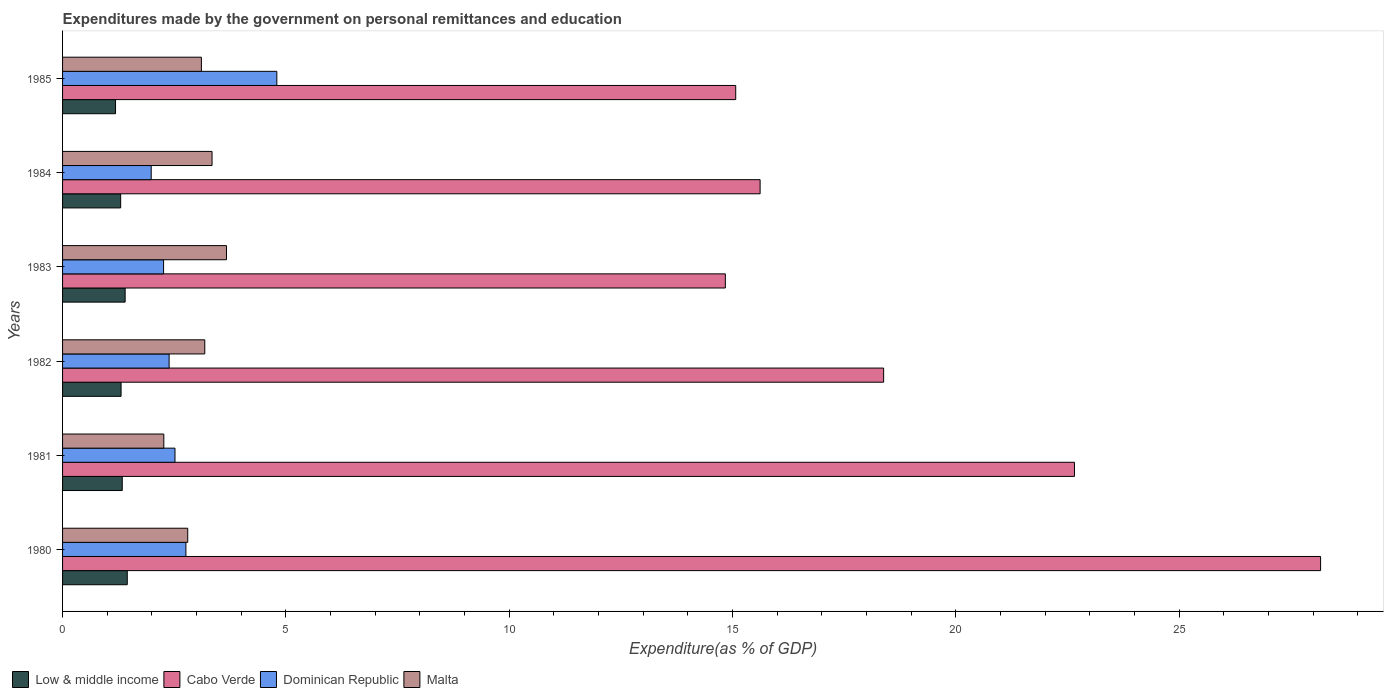How many different coloured bars are there?
Your answer should be compact. 4. Are the number of bars per tick equal to the number of legend labels?
Provide a short and direct response. Yes. How many bars are there on the 3rd tick from the bottom?
Provide a succinct answer. 4. What is the label of the 1st group of bars from the top?
Your answer should be compact. 1985. In how many cases, is the number of bars for a given year not equal to the number of legend labels?
Your answer should be very brief. 0. What is the expenditures made by the government on personal remittances and education in Low & middle income in 1980?
Offer a very short reply. 1.45. Across all years, what is the maximum expenditures made by the government on personal remittances and education in Cabo Verde?
Provide a succinct answer. 28.17. Across all years, what is the minimum expenditures made by the government on personal remittances and education in Malta?
Offer a terse response. 2.27. In which year was the expenditures made by the government on personal remittances and education in Cabo Verde maximum?
Your answer should be very brief. 1980. What is the total expenditures made by the government on personal remittances and education in Cabo Verde in the graph?
Give a very brief answer. 114.73. What is the difference between the expenditures made by the government on personal remittances and education in Malta in 1982 and that in 1983?
Give a very brief answer. -0.49. What is the difference between the expenditures made by the government on personal remittances and education in Low & middle income in 1983 and the expenditures made by the government on personal remittances and education in Cabo Verde in 1984?
Provide a succinct answer. -14.22. What is the average expenditures made by the government on personal remittances and education in Malta per year?
Offer a very short reply. 3.06. In the year 1981, what is the difference between the expenditures made by the government on personal remittances and education in Dominican Republic and expenditures made by the government on personal remittances and education in Low & middle income?
Your answer should be very brief. 1.18. What is the ratio of the expenditures made by the government on personal remittances and education in Low & middle income in 1980 to that in 1985?
Make the answer very short. 1.22. Is the expenditures made by the government on personal remittances and education in Low & middle income in 1981 less than that in 1983?
Give a very brief answer. Yes. What is the difference between the highest and the second highest expenditures made by the government on personal remittances and education in Dominican Republic?
Your answer should be very brief. 2.04. What is the difference between the highest and the lowest expenditures made by the government on personal remittances and education in Dominican Republic?
Your response must be concise. 2.81. In how many years, is the expenditures made by the government on personal remittances and education in Cabo Verde greater than the average expenditures made by the government on personal remittances and education in Cabo Verde taken over all years?
Give a very brief answer. 2. Is the sum of the expenditures made by the government on personal remittances and education in Dominican Republic in 1981 and 1985 greater than the maximum expenditures made by the government on personal remittances and education in Cabo Verde across all years?
Your answer should be compact. No. What does the 1st bar from the top in 1981 represents?
Offer a terse response. Malta. What does the 1st bar from the bottom in 1985 represents?
Provide a succinct answer. Low & middle income. Is it the case that in every year, the sum of the expenditures made by the government on personal remittances and education in Dominican Republic and expenditures made by the government on personal remittances and education in Cabo Verde is greater than the expenditures made by the government on personal remittances and education in Malta?
Offer a very short reply. Yes. How many bars are there?
Ensure brevity in your answer.  24. Are all the bars in the graph horizontal?
Offer a very short reply. Yes. Does the graph contain any zero values?
Your answer should be very brief. No. Does the graph contain grids?
Offer a terse response. No. How many legend labels are there?
Ensure brevity in your answer.  4. How are the legend labels stacked?
Keep it short and to the point. Horizontal. What is the title of the graph?
Offer a very short reply. Expenditures made by the government on personal remittances and education. What is the label or title of the X-axis?
Your answer should be compact. Expenditure(as % of GDP). What is the label or title of the Y-axis?
Keep it short and to the point. Years. What is the Expenditure(as % of GDP) in Low & middle income in 1980?
Provide a short and direct response. 1.45. What is the Expenditure(as % of GDP) of Cabo Verde in 1980?
Ensure brevity in your answer.  28.17. What is the Expenditure(as % of GDP) in Dominican Republic in 1980?
Offer a terse response. 2.76. What is the Expenditure(as % of GDP) in Malta in 1980?
Keep it short and to the point. 2.8. What is the Expenditure(as % of GDP) in Low & middle income in 1981?
Your answer should be compact. 1.34. What is the Expenditure(as % of GDP) in Cabo Verde in 1981?
Offer a very short reply. 22.66. What is the Expenditure(as % of GDP) in Dominican Republic in 1981?
Provide a succinct answer. 2.52. What is the Expenditure(as % of GDP) in Malta in 1981?
Your response must be concise. 2.27. What is the Expenditure(as % of GDP) in Low & middle income in 1982?
Your answer should be very brief. 1.31. What is the Expenditure(as % of GDP) in Cabo Verde in 1982?
Offer a very short reply. 18.38. What is the Expenditure(as % of GDP) in Dominican Republic in 1982?
Provide a short and direct response. 2.39. What is the Expenditure(as % of GDP) of Malta in 1982?
Your response must be concise. 3.18. What is the Expenditure(as % of GDP) in Low & middle income in 1983?
Your answer should be compact. 1.4. What is the Expenditure(as % of GDP) of Cabo Verde in 1983?
Offer a terse response. 14.84. What is the Expenditure(as % of GDP) of Dominican Republic in 1983?
Offer a terse response. 2.26. What is the Expenditure(as % of GDP) of Malta in 1983?
Give a very brief answer. 3.67. What is the Expenditure(as % of GDP) of Low & middle income in 1984?
Keep it short and to the point. 1.3. What is the Expenditure(as % of GDP) in Cabo Verde in 1984?
Give a very brief answer. 15.62. What is the Expenditure(as % of GDP) of Dominican Republic in 1984?
Provide a short and direct response. 1.98. What is the Expenditure(as % of GDP) in Malta in 1984?
Give a very brief answer. 3.35. What is the Expenditure(as % of GDP) in Low & middle income in 1985?
Ensure brevity in your answer.  1.19. What is the Expenditure(as % of GDP) of Cabo Verde in 1985?
Your response must be concise. 15.07. What is the Expenditure(as % of GDP) of Dominican Republic in 1985?
Provide a short and direct response. 4.8. What is the Expenditure(as % of GDP) in Malta in 1985?
Offer a terse response. 3.11. Across all years, what is the maximum Expenditure(as % of GDP) of Low & middle income?
Make the answer very short. 1.45. Across all years, what is the maximum Expenditure(as % of GDP) in Cabo Verde?
Make the answer very short. 28.17. Across all years, what is the maximum Expenditure(as % of GDP) of Dominican Republic?
Keep it short and to the point. 4.8. Across all years, what is the maximum Expenditure(as % of GDP) of Malta?
Make the answer very short. 3.67. Across all years, what is the minimum Expenditure(as % of GDP) in Low & middle income?
Keep it short and to the point. 1.19. Across all years, what is the minimum Expenditure(as % of GDP) in Cabo Verde?
Your response must be concise. 14.84. Across all years, what is the minimum Expenditure(as % of GDP) of Dominican Republic?
Your answer should be very brief. 1.98. Across all years, what is the minimum Expenditure(as % of GDP) of Malta?
Ensure brevity in your answer.  2.27. What is the total Expenditure(as % of GDP) of Low & middle income in the graph?
Provide a short and direct response. 7.98. What is the total Expenditure(as % of GDP) of Cabo Verde in the graph?
Offer a very short reply. 114.73. What is the total Expenditure(as % of GDP) of Dominican Republic in the graph?
Give a very brief answer. 16.71. What is the total Expenditure(as % of GDP) in Malta in the graph?
Your response must be concise. 18.38. What is the difference between the Expenditure(as % of GDP) in Low & middle income in 1980 and that in 1981?
Ensure brevity in your answer.  0.11. What is the difference between the Expenditure(as % of GDP) in Cabo Verde in 1980 and that in 1981?
Make the answer very short. 5.51. What is the difference between the Expenditure(as % of GDP) in Dominican Republic in 1980 and that in 1981?
Provide a short and direct response. 0.24. What is the difference between the Expenditure(as % of GDP) in Malta in 1980 and that in 1981?
Your answer should be compact. 0.54. What is the difference between the Expenditure(as % of GDP) in Low & middle income in 1980 and that in 1982?
Ensure brevity in your answer.  0.14. What is the difference between the Expenditure(as % of GDP) of Cabo Verde in 1980 and that in 1982?
Your answer should be very brief. 9.78. What is the difference between the Expenditure(as % of GDP) in Dominican Republic in 1980 and that in 1982?
Provide a succinct answer. 0.38. What is the difference between the Expenditure(as % of GDP) in Malta in 1980 and that in 1982?
Your response must be concise. -0.38. What is the difference between the Expenditure(as % of GDP) in Low & middle income in 1980 and that in 1983?
Your answer should be compact. 0.05. What is the difference between the Expenditure(as % of GDP) in Cabo Verde in 1980 and that in 1983?
Offer a terse response. 13.33. What is the difference between the Expenditure(as % of GDP) in Dominican Republic in 1980 and that in 1983?
Give a very brief answer. 0.5. What is the difference between the Expenditure(as % of GDP) in Malta in 1980 and that in 1983?
Give a very brief answer. -0.87. What is the difference between the Expenditure(as % of GDP) of Low & middle income in 1980 and that in 1984?
Your response must be concise. 0.15. What is the difference between the Expenditure(as % of GDP) of Cabo Verde in 1980 and that in 1984?
Ensure brevity in your answer.  12.55. What is the difference between the Expenditure(as % of GDP) of Dominican Republic in 1980 and that in 1984?
Provide a succinct answer. 0.78. What is the difference between the Expenditure(as % of GDP) in Malta in 1980 and that in 1984?
Your answer should be very brief. -0.54. What is the difference between the Expenditure(as % of GDP) of Low & middle income in 1980 and that in 1985?
Your answer should be compact. 0.26. What is the difference between the Expenditure(as % of GDP) in Cabo Verde in 1980 and that in 1985?
Give a very brief answer. 13.09. What is the difference between the Expenditure(as % of GDP) in Dominican Republic in 1980 and that in 1985?
Keep it short and to the point. -2.04. What is the difference between the Expenditure(as % of GDP) in Malta in 1980 and that in 1985?
Give a very brief answer. -0.31. What is the difference between the Expenditure(as % of GDP) in Low & middle income in 1981 and that in 1982?
Offer a terse response. 0.03. What is the difference between the Expenditure(as % of GDP) of Cabo Verde in 1981 and that in 1982?
Ensure brevity in your answer.  4.27. What is the difference between the Expenditure(as % of GDP) of Dominican Republic in 1981 and that in 1982?
Your response must be concise. 0.13. What is the difference between the Expenditure(as % of GDP) in Malta in 1981 and that in 1982?
Give a very brief answer. -0.92. What is the difference between the Expenditure(as % of GDP) in Low & middle income in 1981 and that in 1983?
Provide a succinct answer. -0.06. What is the difference between the Expenditure(as % of GDP) in Cabo Verde in 1981 and that in 1983?
Your answer should be compact. 7.82. What is the difference between the Expenditure(as % of GDP) in Dominican Republic in 1981 and that in 1983?
Your answer should be very brief. 0.26. What is the difference between the Expenditure(as % of GDP) of Malta in 1981 and that in 1983?
Give a very brief answer. -1.4. What is the difference between the Expenditure(as % of GDP) of Low & middle income in 1981 and that in 1984?
Your answer should be compact. 0.04. What is the difference between the Expenditure(as % of GDP) in Cabo Verde in 1981 and that in 1984?
Your answer should be compact. 7.04. What is the difference between the Expenditure(as % of GDP) in Dominican Republic in 1981 and that in 1984?
Provide a succinct answer. 0.53. What is the difference between the Expenditure(as % of GDP) in Malta in 1981 and that in 1984?
Your answer should be compact. -1.08. What is the difference between the Expenditure(as % of GDP) in Low & middle income in 1981 and that in 1985?
Offer a terse response. 0.15. What is the difference between the Expenditure(as % of GDP) of Cabo Verde in 1981 and that in 1985?
Offer a terse response. 7.58. What is the difference between the Expenditure(as % of GDP) of Dominican Republic in 1981 and that in 1985?
Keep it short and to the point. -2.28. What is the difference between the Expenditure(as % of GDP) in Malta in 1981 and that in 1985?
Ensure brevity in your answer.  -0.84. What is the difference between the Expenditure(as % of GDP) in Low & middle income in 1982 and that in 1983?
Provide a succinct answer. -0.09. What is the difference between the Expenditure(as % of GDP) in Cabo Verde in 1982 and that in 1983?
Offer a very short reply. 3.54. What is the difference between the Expenditure(as % of GDP) of Dominican Republic in 1982 and that in 1983?
Keep it short and to the point. 0.12. What is the difference between the Expenditure(as % of GDP) of Malta in 1982 and that in 1983?
Offer a very short reply. -0.49. What is the difference between the Expenditure(as % of GDP) of Low & middle income in 1982 and that in 1984?
Your answer should be compact. 0.01. What is the difference between the Expenditure(as % of GDP) in Cabo Verde in 1982 and that in 1984?
Offer a very short reply. 2.77. What is the difference between the Expenditure(as % of GDP) of Dominican Republic in 1982 and that in 1984?
Offer a very short reply. 0.4. What is the difference between the Expenditure(as % of GDP) of Malta in 1982 and that in 1984?
Your answer should be compact. -0.16. What is the difference between the Expenditure(as % of GDP) in Low & middle income in 1982 and that in 1985?
Provide a short and direct response. 0.12. What is the difference between the Expenditure(as % of GDP) in Cabo Verde in 1982 and that in 1985?
Offer a terse response. 3.31. What is the difference between the Expenditure(as % of GDP) of Dominican Republic in 1982 and that in 1985?
Provide a succinct answer. -2.41. What is the difference between the Expenditure(as % of GDP) in Malta in 1982 and that in 1985?
Make the answer very short. 0.08. What is the difference between the Expenditure(as % of GDP) of Low & middle income in 1983 and that in 1984?
Keep it short and to the point. 0.1. What is the difference between the Expenditure(as % of GDP) in Cabo Verde in 1983 and that in 1984?
Make the answer very short. -0.78. What is the difference between the Expenditure(as % of GDP) in Dominican Republic in 1983 and that in 1984?
Keep it short and to the point. 0.28. What is the difference between the Expenditure(as % of GDP) in Malta in 1983 and that in 1984?
Offer a terse response. 0.32. What is the difference between the Expenditure(as % of GDP) of Low & middle income in 1983 and that in 1985?
Ensure brevity in your answer.  0.22. What is the difference between the Expenditure(as % of GDP) of Cabo Verde in 1983 and that in 1985?
Make the answer very short. -0.23. What is the difference between the Expenditure(as % of GDP) in Dominican Republic in 1983 and that in 1985?
Keep it short and to the point. -2.54. What is the difference between the Expenditure(as % of GDP) of Malta in 1983 and that in 1985?
Ensure brevity in your answer.  0.56. What is the difference between the Expenditure(as % of GDP) in Low & middle income in 1984 and that in 1985?
Give a very brief answer. 0.11. What is the difference between the Expenditure(as % of GDP) of Cabo Verde in 1984 and that in 1985?
Your answer should be compact. 0.55. What is the difference between the Expenditure(as % of GDP) of Dominican Republic in 1984 and that in 1985?
Your answer should be compact. -2.81. What is the difference between the Expenditure(as % of GDP) in Malta in 1984 and that in 1985?
Your response must be concise. 0.24. What is the difference between the Expenditure(as % of GDP) in Low & middle income in 1980 and the Expenditure(as % of GDP) in Cabo Verde in 1981?
Make the answer very short. -21.21. What is the difference between the Expenditure(as % of GDP) of Low & middle income in 1980 and the Expenditure(as % of GDP) of Dominican Republic in 1981?
Offer a very short reply. -1.07. What is the difference between the Expenditure(as % of GDP) in Low & middle income in 1980 and the Expenditure(as % of GDP) in Malta in 1981?
Your response must be concise. -0.82. What is the difference between the Expenditure(as % of GDP) of Cabo Verde in 1980 and the Expenditure(as % of GDP) of Dominican Republic in 1981?
Make the answer very short. 25.65. What is the difference between the Expenditure(as % of GDP) in Cabo Verde in 1980 and the Expenditure(as % of GDP) in Malta in 1981?
Your answer should be compact. 25.9. What is the difference between the Expenditure(as % of GDP) in Dominican Republic in 1980 and the Expenditure(as % of GDP) in Malta in 1981?
Give a very brief answer. 0.49. What is the difference between the Expenditure(as % of GDP) of Low & middle income in 1980 and the Expenditure(as % of GDP) of Cabo Verde in 1982?
Your response must be concise. -16.93. What is the difference between the Expenditure(as % of GDP) of Low & middle income in 1980 and the Expenditure(as % of GDP) of Dominican Republic in 1982?
Offer a very short reply. -0.94. What is the difference between the Expenditure(as % of GDP) in Low & middle income in 1980 and the Expenditure(as % of GDP) in Malta in 1982?
Ensure brevity in your answer.  -1.74. What is the difference between the Expenditure(as % of GDP) in Cabo Verde in 1980 and the Expenditure(as % of GDP) in Dominican Republic in 1982?
Your answer should be very brief. 25.78. What is the difference between the Expenditure(as % of GDP) in Cabo Verde in 1980 and the Expenditure(as % of GDP) in Malta in 1982?
Your answer should be compact. 24.98. What is the difference between the Expenditure(as % of GDP) of Dominican Republic in 1980 and the Expenditure(as % of GDP) of Malta in 1982?
Your answer should be very brief. -0.42. What is the difference between the Expenditure(as % of GDP) of Low & middle income in 1980 and the Expenditure(as % of GDP) of Cabo Verde in 1983?
Your answer should be compact. -13.39. What is the difference between the Expenditure(as % of GDP) in Low & middle income in 1980 and the Expenditure(as % of GDP) in Dominican Republic in 1983?
Your answer should be compact. -0.81. What is the difference between the Expenditure(as % of GDP) in Low & middle income in 1980 and the Expenditure(as % of GDP) in Malta in 1983?
Your answer should be very brief. -2.22. What is the difference between the Expenditure(as % of GDP) of Cabo Verde in 1980 and the Expenditure(as % of GDP) of Dominican Republic in 1983?
Ensure brevity in your answer.  25.9. What is the difference between the Expenditure(as % of GDP) in Cabo Verde in 1980 and the Expenditure(as % of GDP) in Malta in 1983?
Offer a terse response. 24.5. What is the difference between the Expenditure(as % of GDP) in Dominican Republic in 1980 and the Expenditure(as % of GDP) in Malta in 1983?
Provide a short and direct response. -0.91. What is the difference between the Expenditure(as % of GDP) of Low & middle income in 1980 and the Expenditure(as % of GDP) of Cabo Verde in 1984?
Offer a terse response. -14.17. What is the difference between the Expenditure(as % of GDP) of Low & middle income in 1980 and the Expenditure(as % of GDP) of Dominican Republic in 1984?
Your response must be concise. -0.54. What is the difference between the Expenditure(as % of GDP) in Low & middle income in 1980 and the Expenditure(as % of GDP) in Malta in 1984?
Provide a short and direct response. -1.9. What is the difference between the Expenditure(as % of GDP) in Cabo Verde in 1980 and the Expenditure(as % of GDP) in Dominican Republic in 1984?
Provide a succinct answer. 26.18. What is the difference between the Expenditure(as % of GDP) in Cabo Verde in 1980 and the Expenditure(as % of GDP) in Malta in 1984?
Offer a very short reply. 24.82. What is the difference between the Expenditure(as % of GDP) of Dominican Republic in 1980 and the Expenditure(as % of GDP) of Malta in 1984?
Make the answer very short. -0.59. What is the difference between the Expenditure(as % of GDP) of Low & middle income in 1980 and the Expenditure(as % of GDP) of Cabo Verde in 1985?
Offer a terse response. -13.62. What is the difference between the Expenditure(as % of GDP) in Low & middle income in 1980 and the Expenditure(as % of GDP) in Dominican Republic in 1985?
Make the answer very short. -3.35. What is the difference between the Expenditure(as % of GDP) of Low & middle income in 1980 and the Expenditure(as % of GDP) of Malta in 1985?
Your answer should be very brief. -1.66. What is the difference between the Expenditure(as % of GDP) in Cabo Verde in 1980 and the Expenditure(as % of GDP) in Dominican Republic in 1985?
Offer a very short reply. 23.37. What is the difference between the Expenditure(as % of GDP) of Cabo Verde in 1980 and the Expenditure(as % of GDP) of Malta in 1985?
Your response must be concise. 25.06. What is the difference between the Expenditure(as % of GDP) of Dominican Republic in 1980 and the Expenditure(as % of GDP) of Malta in 1985?
Your answer should be compact. -0.35. What is the difference between the Expenditure(as % of GDP) in Low & middle income in 1981 and the Expenditure(as % of GDP) in Cabo Verde in 1982?
Keep it short and to the point. -17.05. What is the difference between the Expenditure(as % of GDP) of Low & middle income in 1981 and the Expenditure(as % of GDP) of Dominican Republic in 1982?
Give a very brief answer. -1.05. What is the difference between the Expenditure(as % of GDP) of Low & middle income in 1981 and the Expenditure(as % of GDP) of Malta in 1982?
Ensure brevity in your answer.  -1.85. What is the difference between the Expenditure(as % of GDP) of Cabo Verde in 1981 and the Expenditure(as % of GDP) of Dominican Republic in 1982?
Keep it short and to the point. 20.27. What is the difference between the Expenditure(as % of GDP) of Cabo Verde in 1981 and the Expenditure(as % of GDP) of Malta in 1982?
Provide a short and direct response. 19.47. What is the difference between the Expenditure(as % of GDP) in Dominican Republic in 1981 and the Expenditure(as % of GDP) in Malta in 1982?
Provide a succinct answer. -0.67. What is the difference between the Expenditure(as % of GDP) of Low & middle income in 1981 and the Expenditure(as % of GDP) of Cabo Verde in 1983?
Keep it short and to the point. -13.5. What is the difference between the Expenditure(as % of GDP) of Low & middle income in 1981 and the Expenditure(as % of GDP) of Dominican Republic in 1983?
Ensure brevity in your answer.  -0.93. What is the difference between the Expenditure(as % of GDP) in Low & middle income in 1981 and the Expenditure(as % of GDP) in Malta in 1983?
Provide a short and direct response. -2.33. What is the difference between the Expenditure(as % of GDP) in Cabo Verde in 1981 and the Expenditure(as % of GDP) in Dominican Republic in 1983?
Your answer should be compact. 20.39. What is the difference between the Expenditure(as % of GDP) in Cabo Verde in 1981 and the Expenditure(as % of GDP) in Malta in 1983?
Provide a short and direct response. 18.99. What is the difference between the Expenditure(as % of GDP) in Dominican Republic in 1981 and the Expenditure(as % of GDP) in Malta in 1983?
Provide a succinct answer. -1.15. What is the difference between the Expenditure(as % of GDP) in Low & middle income in 1981 and the Expenditure(as % of GDP) in Cabo Verde in 1984?
Keep it short and to the point. -14.28. What is the difference between the Expenditure(as % of GDP) in Low & middle income in 1981 and the Expenditure(as % of GDP) in Dominican Republic in 1984?
Offer a very short reply. -0.65. What is the difference between the Expenditure(as % of GDP) in Low & middle income in 1981 and the Expenditure(as % of GDP) in Malta in 1984?
Ensure brevity in your answer.  -2.01. What is the difference between the Expenditure(as % of GDP) in Cabo Verde in 1981 and the Expenditure(as % of GDP) in Dominican Republic in 1984?
Your answer should be compact. 20.67. What is the difference between the Expenditure(as % of GDP) in Cabo Verde in 1981 and the Expenditure(as % of GDP) in Malta in 1984?
Offer a very short reply. 19.31. What is the difference between the Expenditure(as % of GDP) of Dominican Republic in 1981 and the Expenditure(as % of GDP) of Malta in 1984?
Keep it short and to the point. -0.83. What is the difference between the Expenditure(as % of GDP) in Low & middle income in 1981 and the Expenditure(as % of GDP) in Cabo Verde in 1985?
Offer a terse response. -13.73. What is the difference between the Expenditure(as % of GDP) in Low & middle income in 1981 and the Expenditure(as % of GDP) in Dominican Republic in 1985?
Your answer should be very brief. -3.46. What is the difference between the Expenditure(as % of GDP) of Low & middle income in 1981 and the Expenditure(as % of GDP) of Malta in 1985?
Provide a succinct answer. -1.77. What is the difference between the Expenditure(as % of GDP) of Cabo Verde in 1981 and the Expenditure(as % of GDP) of Dominican Republic in 1985?
Provide a short and direct response. 17.86. What is the difference between the Expenditure(as % of GDP) in Cabo Verde in 1981 and the Expenditure(as % of GDP) in Malta in 1985?
Your answer should be compact. 19.55. What is the difference between the Expenditure(as % of GDP) of Dominican Republic in 1981 and the Expenditure(as % of GDP) of Malta in 1985?
Your answer should be compact. -0.59. What is the difference between the Expenditure(as % of GDP) in Low & middle income in 1982 and the Expenditure(as % of GDP) in Cabo Verde in 1983?
Offer a terse response. -13.53. What is the difference between the Expenditure(as % of GDP) in Low & middle income in 1982 and the Expenditure(as % of GDP) in Dominican Republic in 1983?
Offer a very short reply. -0.95. What is the difference between the Expenditure(as % of GDP) in Low & middle income in 1982 and the Expenditure(as % of GDP) in Malta in 1983?
Offer a terse response. -2.36. What is the difference between the Expenditure(as % of GDP) of Cabo Verde in 1982 and the Expenditure(as % of GDP) of Dominican Republic in 1983?
Your answer should be compact. 16.12. What is the difference between the Expenditure(as % of GDP) in Cabo Verde in 1982 and the Expenditure(as % of GDP) in Malta in 1983?
Give a very brief answer. 14.71. What is the difference between the Expenditure(as % of GDP) of Dominican Republic in 1982 and the Expenditure(as % of GDP) of Malta in 1983?
Offer a very short reply. -1.28. What is the difference between the Expenditure(as % of GDP) of Low & middle income in 1982 and the Expenditure(as % of GDP) of Cabo Verde in 1984?
Ensure brevity in your answer.  -14.31. What is the difference between the Expenditure(as % of GDP) of Low & middle income in 1982 and the Expenditure(as % of GDP) of Dominican Republic in 1984?
Your answer should be compact. -0.67. What is the difference between the Expenditure(as % of GDP) in Low & middle income in 1982 and the Expenditure(as % of GDP) in Malta in 1984?
Make the answer very short. -2.04. What is the difference between the Expenditure(as % of GDP) of Cabo Verde in 1982 and the Expenditure(as % of GDP) of Dominican Republic in 1984?
Provide a short and direct response. 16.4. What is the difference between the Expenditure(as % of GDP) in Cabo Verde in 1982 and the Expenditure(as % of GDP) in Malta in 1984?
Make the answer very short. 15.04. What is the difference between the Expenditure(as % of GDP) in Dominican Republic in 1982 and the Expenditure(as % of GDP) in Malta in 1984?
Provide a succinct answer. -0.96. What is the difference between the Expenditure(as % of GDP) in Low & middle income in 1982 and the Expenditure(as % of GDP) in Cabo Verde in 1985?
Keep it short and to the point. -13.76. What is the difference between the Expenditure(as % of GDP) of Low & middle income in 1982 and the Expenditure(as % of GDP) of Dominican Republic in 1985?
Ensure brevity in your answer.  -3.49. What is the difference between the Expenditure(as % of GDP) in Low & middle income in 1982 and the Expenditure(as % of GDP) in Malta in 1985?
Make the answer very short. -1.8. What is the difference between the Expenditure(as % of GDP) of Cabo Verde in 1982 and the Expenditure(as % of GDP) of Dominican Republic in 1985?
Provide a succinct answer. 13.59. What is the difference between the Expenditure(as % of GDP) in Cabo Verde in 1982 and the Expenditure(as % of GDP) in Malta in 1985?
Offer a very short reply. 15.27. What is the difference between the Expenditure(as % of GDP) in Dominican Republic in 1982 and the Expenditure(as % of GDP) in Malta in 1985?
Your answer should be compact. -0.72. What is the difference between the Expenditure(as % of GDP) of Low & middle income in 1983 and the Expenditure(as % of GDP) of Cabo Verde in 1984?
Give a very brief answer. -14.22. What is the difference between the Expenditure(as % of GDP) in Low & middle income in 1983 and the Expenditure(as % of GDP) in Dominican Republic in 1984?
Give a very brief answer. -0.58. What is the difference between the Expenditure(as % of GDP) of Low & middle income in 1983 and the Expenditure(as % of GDP) of Malta in 1984?
Provide a succinct answer. -1.95. What is the difference between the Expenditure(as % of GDP) in Cabo Verde in 1983 and the Expenditure(as % of GDP) in Dominican Republic in 1984?
Offer a terse response. 12.85. What is the difference between the Expenditure(as % of GDP) in Cabo Verde in 1983 and the Expenditure(as % of GDP) in Malta in 1984?
Offer a very short reply. 11.49. What is the difference between the Expenditure(as % of GDP) of Dominican Republic in 1983 and the Expenditure(as % of GDP) of Malta in 1984?
Make the answer very short. -1.08. What is the difference between the Expenditure(as % of GDP) of Low & middle income in 1983 and the Expenditure(as % of GDP) of Cabo Verde in 1985?
Ensure brevity in your answer.  -13.67. What is the difference between the Expenditure(as % of GDP) of Low & middle income in 1983 and the Expenditure(as % of GDP) of Dominican Republic in 1985?
Ensure brevity in your answer.  -3.4. What is the difference between the Expenditure(as % of GDP) of Low & middle income in 1983 and the Expenditure(as % of GDP) of Malta in 1985?
Make the answer very short. -1.71. What is the difference between the Expenditure(as % of GDP) of Cabo Verde in 1983 and the Expenditure(as % of GDP) of Dominican Republic in 1985?
Keep it short and to the point. 10.04. What is the difference between the Expenditure(as % of GDP) in Cabo Verde in 1983 and the Expenditure(as % of GDP) in Malta in 1985?
Make the answer very short. 11.73. What is the difference between the Expenditure(as % of GDP) of Dominican Republic in 1983 and the Expenditure(as % of GDP) of Malta in 1985?
Provide a succinct answer. -0.85. What is the difference between the Expenditure(as % of GDP) of Low & middle income in 1984 and the Expenditure(as % of GDP) of Cabo Verde in 1985?
Your answer should be compact. -13.77. What is the difference between the Expenditure(as % of GDP) in Low & middle income in 1984 and the Expenditure(as % of GDP) in Dominican Republic in 1985?
Provide a short and direct response. -3.5. What is the difference between the Expenditure(as % of GDP) of Low & middle income in 1984 and the Expenditure(as % of GDP) of Malta in 1985?
Give a very brief answer. -1.81. What is the difference between the Expenditure(as % of GDP) in Cabo Verde in 1984 and the Expenditure(as % of GDP) in Dominican Republic in 1985?
Give a very brief answer. 10.82. What is the difference between the Expenditure(as % of GDP) of Cabo Verde in 1984 and the Expenditure(as % of GDP) of Malta in 1985?
Offer a very short reply. 12.51. What is the difference between the Expenditure(as % of GDP) in Dominican Republic in 1984 and the Expenditure(as % of GDP) in Malta in 1985?
Keep it short and to the point. -1.12. What is the average Expenditure(as % of GDP) in Low & middle income per year?
Your answer should be very brief. 1.33. What is the average Expenditure(as % of GDP) of Cabo Verde per year?
Make the answer very short. 19.12. What is the average Expenditure(as % of GDP) of Dominican Republic per year?
Your answer should be compact. 2.78. What is the average Expenditure(as % of GDP) in Malta per year?
Make the answer very short. 3.06. In the year 1980, what is the difference between the Expenditure(as % of GDP) of Low & middle income and Expenditure(as % of GDP) of Cabo Verde?
Make the answer very short. -26.72. In the year 1980, what is the difference between the Expenditure(as % of GDP) of Low & middle income and Expenditure(as % of GDP) of Dominican Republic?
Offer a very short reply. -1.31. In the year 1980, what is the difference between the Expenditure(as % of GDP) in Low & middle income and Expenditure(as % of GDP) in Malta?
Offer a terse response. -1.35. In the year 1980, what is the difference between the Expenditure(as % of GDP) in Cabo Verde and Expenditure(as % of GDP) in Dominican Republic?
Keep it short and to the point. 25.4. In the year 1980, what is the difference between the Expenditure(as % of GDP) of Cabo Verde and Expenditure(as % of GDP) of Malta?
Ensure brevity in your answer.  25.36. In the year 1980, what is the difference between the Expenditure(as % of GDP) in Dominican Republic and Expenditure(as % of GDP) in Malta?
Ensure brevity in your answer.  -0.04. In the year 1981, what is the difference between the Expenditure(as % of GDP) of Low & middle income and Expenditure(as % of GDP) of Cabo Verde?
Offer a terse response. -21.32. In the year 1981, what is the difference between the Expenditure(as % of GDP) in Low & middle income and Expenditure(as % of GDP) in Dominican Republic?
Provide a short and direct response. -1.18. In the year 1981, what is the difference between the Expenditure(as % of GDP) of Low & middle income and Expenditure(as % of GDP) of Malta?
Offer a very short reply. -0.93. In the year 1981, what is the difference between the Expenditure(as % of GDP) in Cabo Verde and Expenditure(as % of GDP) in Dominican Republic?
Keep it short and to the point. 20.14. In the year 1981, what is the difference between the Expenditure(as % of GDP) of Cabo Verde and Expenditure(as % of GDP) of Malta?
Your answer should be very brief. 20.39. In the year 1981, what is the difference between the Expenditure(as % of GDP) in Dominican Republic and Expenditure(as % of GDP) in Malta?
Your answer should be very brief. 0.25. In the year 1982, what is the difference between the Expenditure(as % of GDP) of Low & middle income and Expenditure(as % of GDP) of Cabo Verde?
Make the answer very short. -17.07. In the year 1982, what is the difference between the Expenditure(as % of GDP) of Low & middle income and Expenditure(as % of GDP) of Dominican Republic?
Ensure brevity in your answer.  -1.08. In the year 1982, what is the difference between the Expenditure(as % of GDP) in Low & middle income and Expenditure(as % of GDP) in Malta?
Keep it short and to the point. -1.87. In the year 1982, what is the difference between the Expenditure(as % of GDP) of Cabo Verde and Expenditure(as % of GDP) of Dominican Republic?
Your answer should be very brief. 16. In the year 1982, what is the difference between the Expenditure(as % of GDP) in Cabo Verde and Expenditure(as % of GDP) in Malta?
Your answer should be very brief. 15.2. In the year 1982, what is the difference between the Expenditure(as % of GDP) in Dominican Republic and Expenditure(as % of GDP) in Malta?
Your answer should be compact. -0.8. In the year 1983, what is the difference between the Expenditure(as % of GDP) of Low & middle income and Expenditure(as % of GDP) of Cabo Verde?
Make the answer very short. -13.44. In the year 1983, what is the difference between the Expenditure(as % of GDP) in Low & middle income and Expenditure(as % of GDP) in Dominican Republic?
Your answer should be very brief. -0.86. In the year 1983, what is the difference between the Expenditure(as % of GDP) of Low & middle income and Expenditure(as % of GDP) of Malta?
Ensure brevity in your answer.  -2.27. In the year 1983, what is the difference between the Expenditure(as % of GDP) of Cabo Verde and Expenditure(as % of GDP) of Dominican Republic?
Your response must be concise. 12.58. In the year 1983, what is the difference between the Expenditure(as % of GDP) of Cabo Verde and Expenditure(as % of GDP) of Malta?
Make the answer very short. 11.17. In the year 1983, what is the difference between the Expenditure(as % of GDP) of Dominican Republic and Expenditure(as % of GDP) of Malta?
Your response must be concise. -1.41. In the year 1984, what is the difference between the Expenditure(as % of GDP) in Low & middle income and Expenditure(as % of GDP) in Cabo Verde?
Keep it short and to the point. -14.32. In the year 1984, what is the difference between the Expenditure(as % of GDP) in Low & middle income and Expenditure(as % of GDP) in Dominican Republic?
Keep it short and to the point. -0.68. In the year 1984, what is the difference between the Expenditure(as % of GDP) in Low & middle income and Expenditure(as % of GDP) in Malta?
Your response must be concise. -2.05. In the year 1984, what is the difference between the Expenditure(as % of GDP) in Cabo Verde and Expenditure(as % of GDP) in Dominican Republic?
Your answer should be very brief. 13.63. In the year 1984, what is the difference between the Expenditure(as % of GDP) in Cabo Verde and Expenditure(as % of GDP) in Malta?
Provide a succinct answer. 12.27. In the year 1984, what is the difference between the Expenditure(as % of GDP) in Dominican Republic and Expenditure(as % of GDP) in Malta?
Your response must be concise. -1.36. In the year 1985, what is the difference between the Expenditure(as % of GDP) of Low & middle income and Expenditure(as % of GDP) of Cabo Verde?
Your answer should be very brief. -13.89. In the year 1985, what is the difference between the Expenditure(as % of GDP) of Low & middle income and Expenditure(as % of GDP) of Dominican Republic?
Give a very brief answer. -3.61. In the year 1985, what is the difference between the Expenditure(as % of GDP) of Low & middle income and Expenditure(as % of GDP) of Malta?
Give a very brief answer. -1.92. In the year 1985, what is the difference between the Expenditure(as % of GDP) in Cabo Verde and Expenditure(as % of GDP) in Dominican Republic?
Provide a short and direct response. 10.27. In the year 1985, what is the difference between the Expenditure(as % of GDP) of Cabo Verde and Expenditure(as % of GDP) of Malta?
Your answer should be compact. 11.96. In the year 1985, what is the difference between the Expenditure(as % of GDP) of Dominican Republic and Expenditure(as % of GDP) of Malta?
Offer a terse response. 1.69. What is the ratio of the Expenditure(as % of GDP) in Low & middle income in 1980 to that in 1981?
Offer a very short reply. 1.08. What is the ratio of the Expenditure(as % of GDP) in Cabo Verde in 1980 to that in 1981?
Ensure brevity in your answer.  1.24. What is the ratio of the Expenditure(as % of GDP) of Dominican Republic in 1980 to that in 1981?
Make the answer very short. 1.1. What is the ratio of the Expenditure(as % of GDP) in Malta in 1980 to that in 1981?
Your response must be concise. 1.24. What is the ratio of the Expenditure(as % of GDP) of Low & middle income in 1980 to that in 1982?
Provide a short and direct response. 1.11. What is the ratio of the Expenditure(as % of GDP) of Cabo Verde in 1980 to that in 1982?
Offer a terse response. 1.53. What is the ratio of the Expenditure(as % of GDP) of Dominican Republic in 1980 to that in 1982?
Make the answer very short. 1.16. What is the ratio of the Expenditure(as % of GDP) of Low & middle income in 1980 to that in 1983?
Offer a terse response. 1.03. What is the ratio of the Expenditure(as % of GDP) in Cabo Verde in 1980 to that in 1983?
Keep it short and to the point. 1.9. What is the ratio of the Expenditure(as % of GDP) in Dominican Republic in 1980 to that in 1983?
Offer a very short reply. 1.22. What is the ratio of the Expenditure(as % of GDP) of Malta in 1980 to that in 1983?
Your response must be concise. 0.76. What is the ratio of the Expenditure(as % of GDP) in Low & middle income in 1980 to that in 1984?
Keep it short and to the point. 1.11. What is the ratio of the Expenditure(as % of GDP) in Cabo Verde in 1980 to that in 1984?
Offer a very short reply. 1.8. What is the ratio of the Expenditure(as % of GDP) in Dominican Republic in 1980 to that in 1984?
Provide a short and direct response. 1.39. What is the ratio of the Expenditure(as % of GDP) of Malta in 1980 to that in 1984?
Offer a very short reply. 0.84. What is the ratio of the Expenditure(as % of GDP) in Low & middle income in 1980 to that in 1985?
Make the answer very short. 1.22. What is the ratio of the Expenditure(as % of GDP) in Cabo Verde in 1980 to that in 1985?
Offer a terse response. 1.87. What is the ratio of the Expenditure(as % of GDP) of Dominican Republic in 1980 to that in 1985?
Your response must be concise. 0.58. What is the ratio of the Expenditure(as % of GDP) of Malta in 1980 to that in 1985?
Provide a short and direct response. 0.9. What is the ratio of the Expenditure(as % of GDP) in Cabo Verde in 1981 to that in 1982?
Keep it short and to the point. 1.23. What is the ratio of the Expenditure(as % of GDP) in Dominican Republic in 1981 to that in 1982?
Give a very brief answer. 1.05. What is the ratio of the Expenditure(as % of GDP) of Malta in 1981 to that in 1982?
Keep it short and to the point. 0.71. What is the ratio of the Expenditure(as % of GDP) of Low & middle income in 1981 to that in 1983?
Give a very brief answer. 0.95. What is the ratio of the Expenditure(as % of GDP) in Cabo Verde in 1981 to that in 1983?
Provide a short and direct response. 1.53. What is the ratio of the Expenditure(as % of GDP) in Dominican Republic in 1981 to that in 1983?
Your response must be concise. 1.11. What is the ratio of the Expenditure(as % of GDP) of Malta in 1981 to that in 1983?
Your answer should be compact. 0.62. What is the ratio of the Expenditure(as % of GDP) in Low & middle income in 1981 to that in 1984?
Provide a succinct answer. 1.03. What is the ratio of the Expenditure(as % of GDP) in Cabo Verde in 1981 to that in 1984?
Ensure brevity in your answer.  1.45. What is the ratio of the Expenditure(as % of GDP) of Dominican Republic in 1981 to that in 1984?
Provide a succinct answer. 1.27. What is the ratio of the Expenditure(as % of GDP) in Malta in 1981 to that in 1984?
Offer a very short reply. 0.68. What is the ratio of the Expenditure(as % of GDP) of Low & middle income in 1981 to that in 1985?
Your answer should be compact. 1.13. What is the ratio of the Expenditure(as % of GDP) in Cabo Verde in 1981 to that in 1985?
Make the answer very short. 1.5. What is the ratio of the Expenditure(as % of GDP) in Dominican Republic in 1981 to that in 1985?
Keep it short and to the point. 0.52. What is the ratio of the Expenditure(as % of GDP) in Malta in 1981 to that in 1985?
Give a very brief answer. 0.73. What is the ratio of the Expenditure(as % of GDP) in Low & middle income in 1982 to that in 1983?
Your answer should be very brief. 0.94. What is the ratio of the Expenditure(as % of GDP) in Cabo Verde in 1982 to that in 1983?
Make the answer very short. 1.24. What is the ratio of the Expenditure(as % of GDP) of Dominican Republic in 1982 to that in 1983?
Your answer should be compact. 1.05. What is the ratio of the Expenditure(as % of GDP) of Malta in 1982 to that in 1983?
Offer a very short reply. 0.87. What is the ratio of the Expenditure(as % of GDP) in Low & middle income in 1982 to that in 1984?
Ensure brevity in your answer.  1.01. What is the ratio of the Expenditure(as % of GDP) of Cabo Verde in 1982 to that in 1984?
Offer a very short reply. 1.18. What is the ratio of the Expenditure(as % of GDP) in Dominican Republic in 1982 to that in 1984?
Offer a very short reply. 1.2. What is the ratio of the Expenditure(as % of GDP) of Malta in 1982 to that in 1984?
Your response must be concise. 0.95. What is the ratio of the Expenditure(as % of GDP) of Low & middle income in 1982 to that in 1985?
Provide a short and direct response. 1.1. What is the ratio of the Expenditure(as % of GDP) of Cabo Verde in 1982 to that in 1985?
Give a very brief answer. 1.22. What is the ratio of the Expenditure(as % of GDP) of Dominican Republic in 1982 to that in 1985?
Offer a very short reply. 0.5. What is the ratio of the Expenditure(as % of GDP) of Malta in 1982 to that in 1985?
Offer a very short reply. 1.02. What is the ratio of the Expenditure(as % of GDP) of Low & middle income in 1983 to that in 1984?
Your answer should be very brief. 1.08. What is the ratio of the Expenditure(as % of GDP) of Cabo Verde in 1983 to that in 1984?
Your answer should be very brief. 0.95. What is the ratio of the Expenditure(as % of GDP) of Dominican Republic in 1983 to that in 1984?
Ensure brevity in your answer.  1.14. What is the ratio of the Expenditure(as % of GDP) in Malta in 1983 to that in 1984?
Your answer should be very brief. 1.1. What is the ratio of the Expenditure(as % of GDP) in Low & middle income in 1983 to that in 1985?
Keep it short and to the point. 1.18. What is the ratio of the Expenditure(as % of GDP) of Cabo Verde in 1983 to that in 1985?
Ensure brevity in your answer.  0.98. What is the ratio of the Expenditure(as % of GDP) of Dominican Republic in 1983 to that in 1985?
Provide a short and direct response. 0.47. What is the ratio of the Expenditure(as % of GDP) of Malta in 1983 to that in 1985?
Offer a very short reply. 1.18. What is the ratio of the Expenditure(as % of GDP) of Low & middle income in 1984 to that in 1985?
Keep it short and to the point. 1.1. What is the ratio of the Expenditure(as % of GDP) in Cabo Verde in 1984 to that in 1985?
Keep it short and to the point. 1.04. What is the ratio of the Expenditure(as % of GDP) in Dominican Republic in 1984 to that in 1985?
Your answer should be compact. 0.41. What is the ratio of the Expenditure(as % of GDP) in Malta in 1984 to that in 1985?
Your answer should be compact. 1.08. What is the difference between the highest and the second highest Expenditure(as % of GDP) of Low & middle income?
Ensure brevity in your answer.  0.05. What is the difference between the highest and the second highest Expenditure(as % of GDP) of Cabo Verde?
Provide a short and direct response. 5.51. What is the difference between the highest and the second highest Expenditure(as % of GDP) in Dominican Republic?
Your answer should be compact. 2.04. What is the difference between the highest and the second highest Expenditure(as % of GDP) of Malta?
Your response must be concise. 0.32. What is the difference between the highest and the lowest Expenditure(as % of GDP) of Low & middle income?
Give a very brief answer. 0.26. What is the difference between the highest and the lowest Expenditure(as % of GDP) in Cabo Verde?
Your response must be concise. 13.33. What is the difference between the highest and the lowest Expenditure(as % of GDP) in Dominican Republic?
Ensure brevity in your answer.  2.81. What is the difference between the highest and the lowest Expenditure(as % of GDP) of Malta?
Make the answer very short. 1.4. 